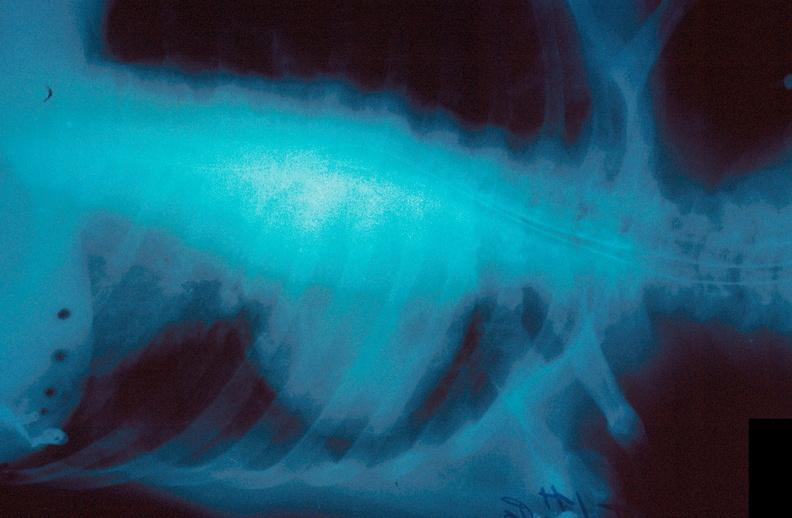s respiratory present?
Answer the question using a single word or phrase. Yes 